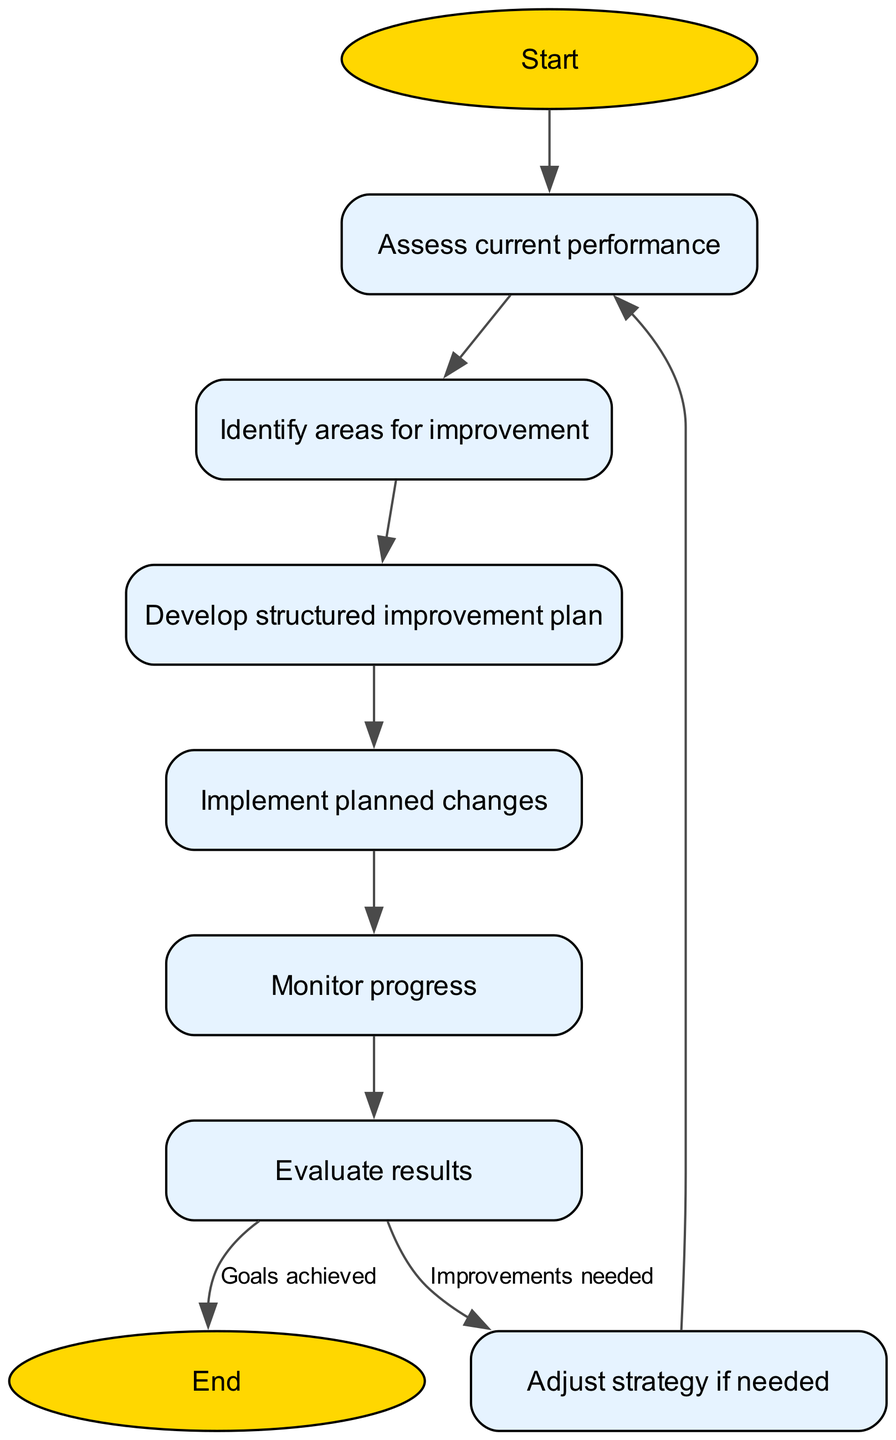What is the first step in the cycle? The diagram starts with the "Start" node leading to "Assess current performance." Therefore, the first step is "Assess current performance."
Answer: Assess current performance How many nodes are in this diagram? Counting all the different nodes listed in the data, there are a total of 9 nodes: start, assess, identify, plan, implement, monitor, evaluate, adjust, and end.
Answer: 9 What happens after "Evaluate results" if improvements are needed? According to the edges defined in the data, after "Evaluate results," if improvements are needed, the flow moves to "Adjust strategy if needed," indicating that adjustments will be made before reassessing.
Answer: Adjust strategy if needed How many edges are present in the diagram? By examining the edges listed in the data, there are a total of 8 edges connecting the nodes together, showing the flow direction.
Answer: 8 What is the final step when all goals are achieved? The flow chart specifies that if "Evaluate results" leads to "Goals achieved," the final step is to "End," terminating the cycle.
Answer: End In which step do we identify areas for improvement? The diagram indicates that "Identify areas for improvement" is the step that follows "Assess current performance," signifying when we pinpoint what needs enhancement.
Answer: Identify areas for improvement What action follows "Implement planned changes"? According to the flow chart, after "Implement planned changes," the next action to take is "Monitor progress," which means tracking the effectiveness of the changes made.
Answer: Monitor progress What is the outcome if we need to adjust the strategy? If the evaluation indicates that improvements are needed, the outcome is to go back to the "Assess current performance" step again for reevaluation, closing the loop in the cycle.
Answer: Assess current performance 